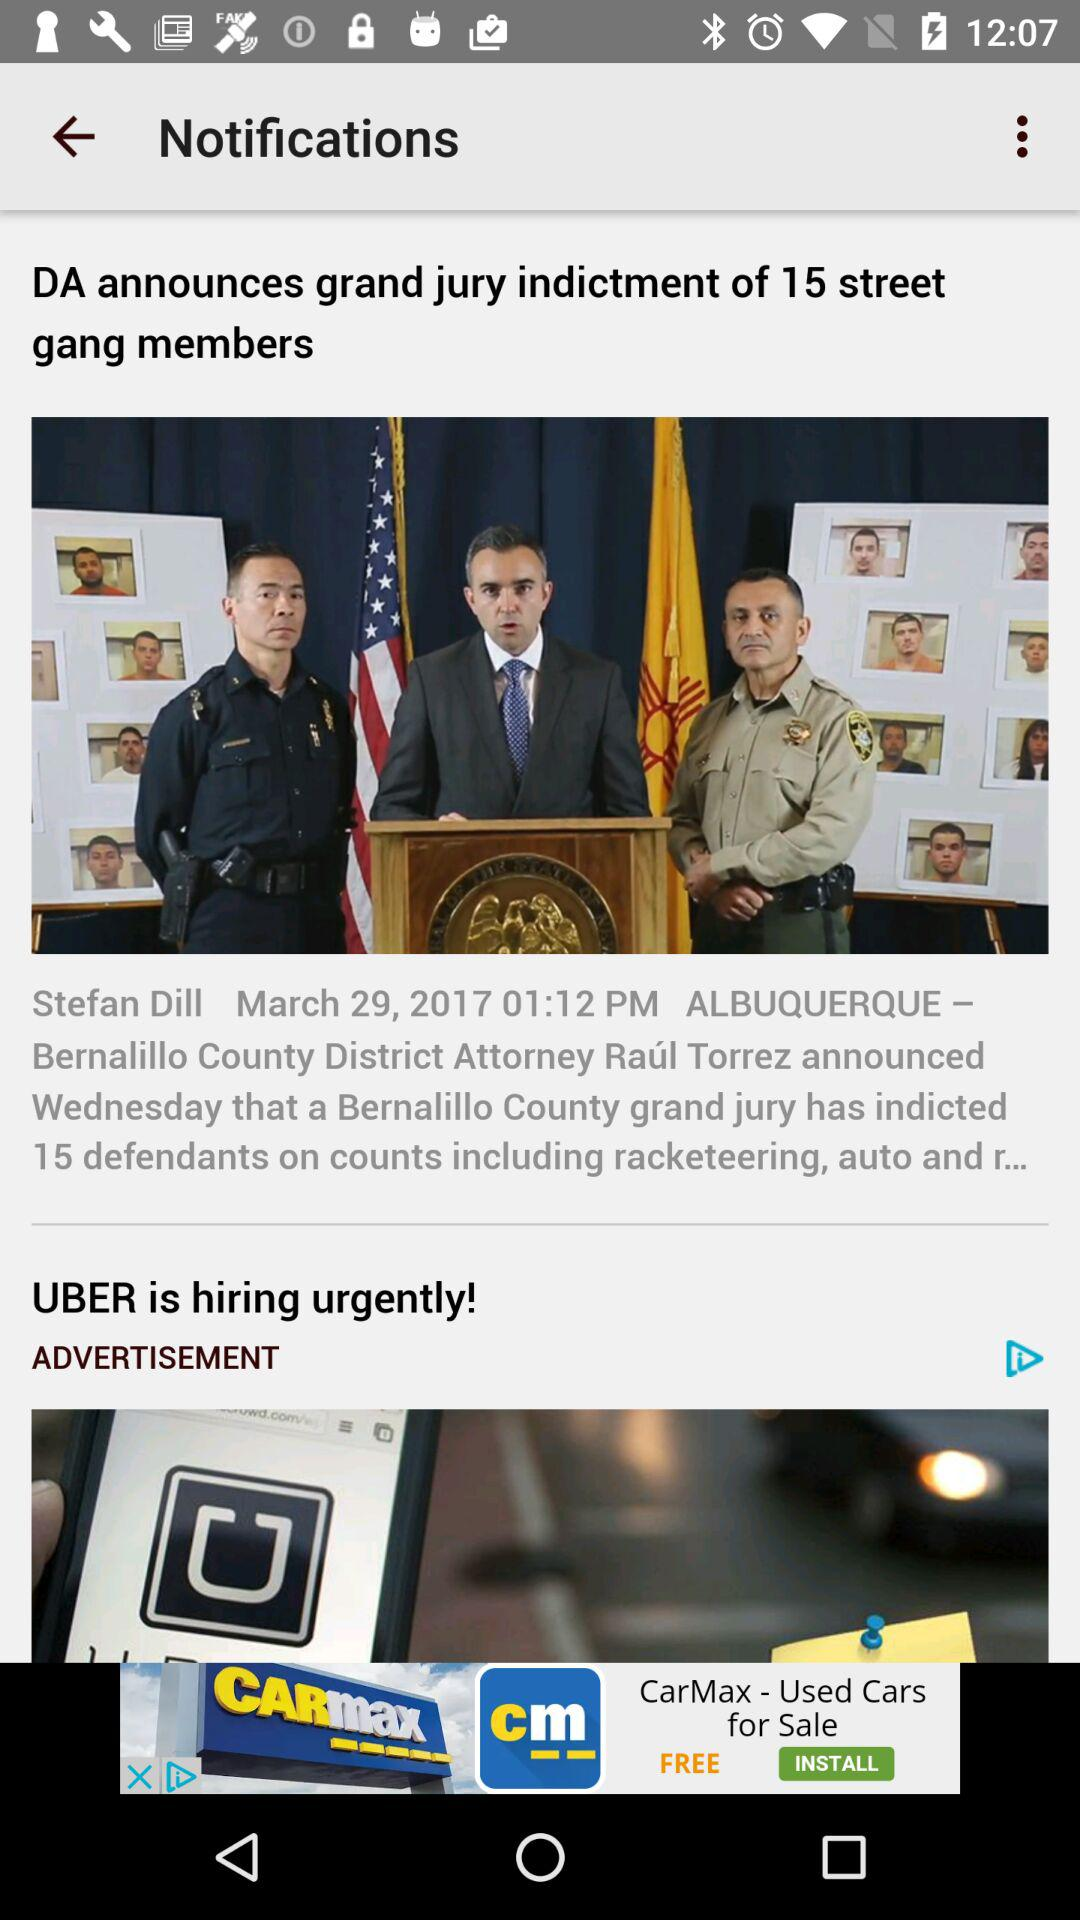What is the date? The date is March 29, 2017. 